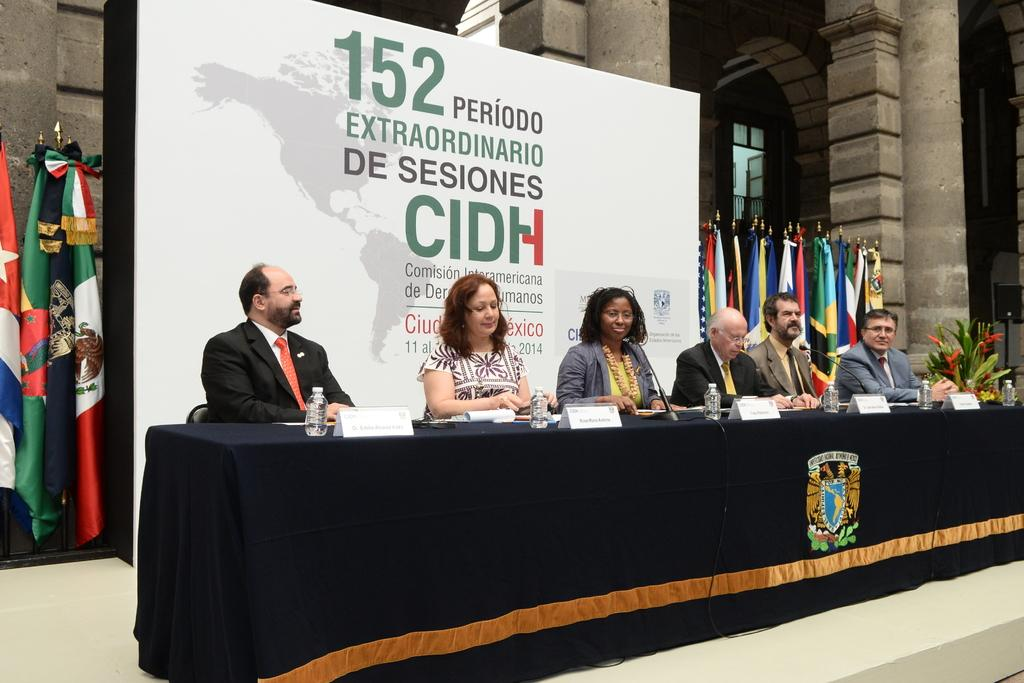What are the people in the image doing? The people in the image are sitting. What objects are visible that might be used for communication? Microphones are visible in the image. What items can be seen on the table in the image? Bottles, papers, and a plant are on the table in the image. What can be seen in the background of the image? Flags, banners, and pillars are visible in the background of the image. What type of riddle is being solved by the people in the image? There is no riddle present in the image; the people are simply sitting. What game are the people playing in the image? There is no game being played in the image; the people are sitting. 